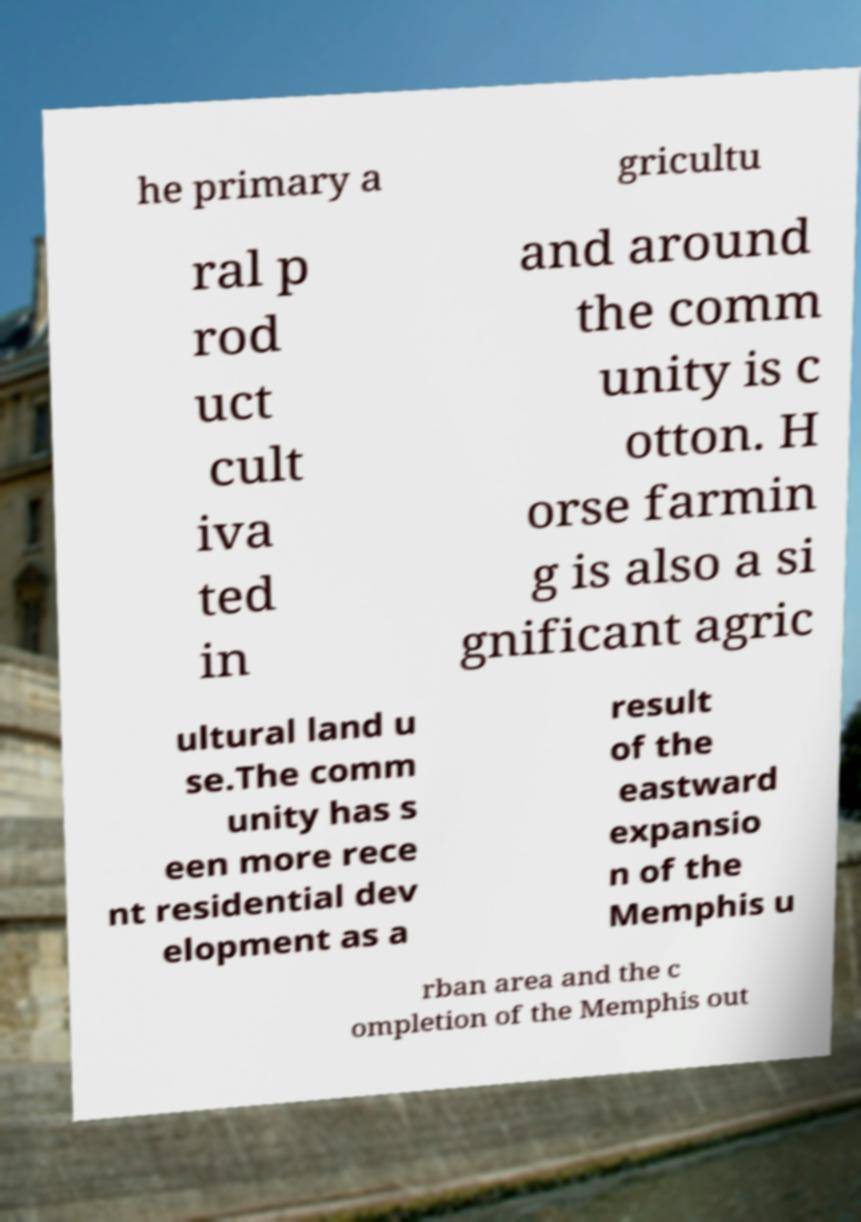Can you read and provide the text displayed in the image?This photo seems to have some interesting text. Can you extract and type it out for me? he primary a gricultu ral p rod uct cult iva ted in and around the comm unity is c otton. H orse farmin g is also a si gnificant agric ultural land u se.The comm unity has s een more rece nt residential dev elopment as a result of the eastward expansio n of the Memphis u rban area and the c ompletion of the Memphis out 